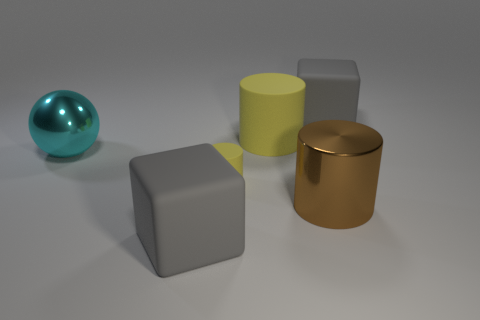How do the textures of the objects in the image vary? The objects in the image present a variety of textures. The spherical object has a smooth, glossy finish that reflects its surroundings, indicating a possible metallic or glass-like material. The cube and cylinder in the middle have a matte finish, suggesting a more diffuse reflection typical of plastics or painted surfaces, whereas the copper-toned cylinder has a polished metallic texture, similar to the sphere but with a different sheen due to its material properties. 